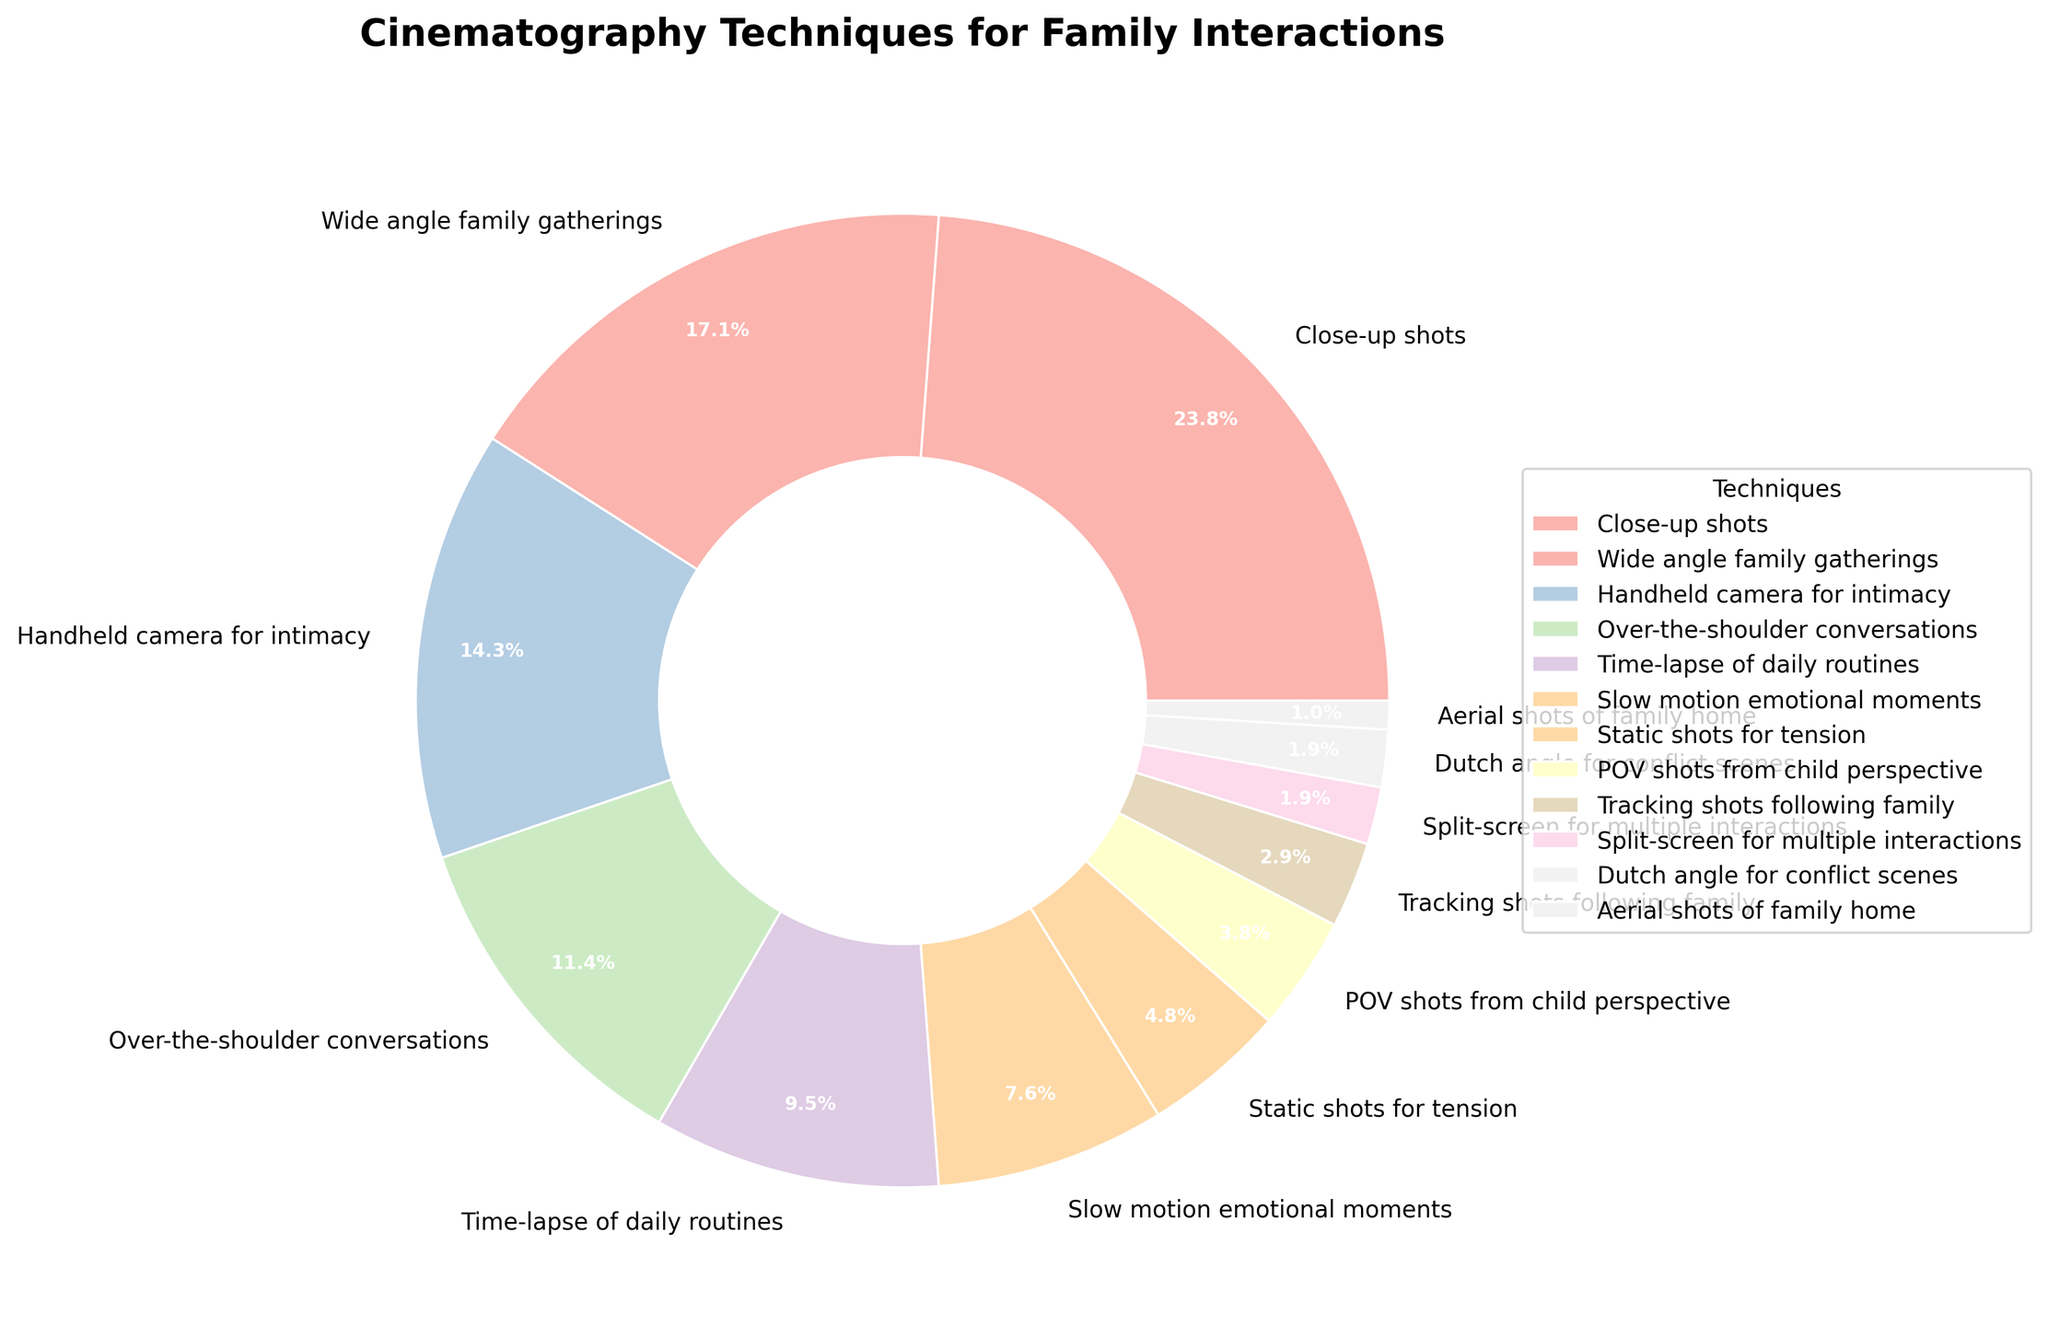what percentage of the chart is represented by Close-up shots, Wide angle family gatherings, and Handheld camera for intimacy? Close-up shots represent 25%, Wide angle family gatherings represent 18%, and Handheld camera for intimacy represents 15%. Adding these percentages: 25% + 18% + 15% = 58%.
Answer: 58% Which cinematography technique has the smallest percentage in the chart? The chart shows aerial shots of family home at 1%, which is the smallest percentage represented.
Answer: Aerial shots of family home Is the percentage for Slow motion emotional moments greater than the combined percentage of Dutch angle for conflict scenes and Split-screen for multiple interactions? Slow motion emotional moments have a percentage of 8%. Together, Dutch angle for conflict scenes and Split-screen for multiple interactions sum to 2% + 2% = 4%. Therefore, 8% is greater than 4%.
Answer: Yes What is the visual distinguishing feature of the wedges representing Close-up shots and Wide angle family gatherings? Close-up shots and Wide angle family gatherings are distinguished by their proportions relative to the other segments. Close-up shots show a larger segment (25%) compared to Wide angle family gatherings (18%). Their colors and positions around the pie chart also help distinguish them.
Answer: Larger size for Close-up shots Which three techniques together form approximately half of the chart? Close-up shots (25%), Wide angle family gatherings (18%), and Handheld camera for intimacy (15%) together form 25% + 18% + 15% = 58%, which is slightly more than half of the chart.
Answer: Close-up shots, Wide angle family gatherings, Handheld camera for intimacy How does the percentage for Over-the-shoulder conversations compare to that of Time-lapse of daily routines? Over-the-shoulder conversations have a percentage of 12%, while Time-lapse of daily routines have a percentage of 10%. Therefore, Over-the-shoulder conversations have a higher percentage.
Answer: More What percentage do Slow motion emotional moments and Static shots for tension represent together? Slow motion emotional moments represent 8% and Static shots for tension represent 5%. Adding these: 8% + 5% = 13%.
Answer: 13% Which technique has a percentage closest to the value represented by Tracking shots following family? The percentage for Tracking shots following family is 3%. The closest percentage is from Split-screen for multiple interactions and Dutch angle for conflict scenes, each at 2%.
Answer: Split-screen for multiple interactions, Dutch angle for conflict scenes Describe the color of the wedge for POV shots from child perspective. Without specifying exact coding details, wedges in pie charts typically use distinct colors. POV shots from child perspective likely have their unique pastel color, different from other segments, which helps in identifying them visually.
Answer: Unique pastel color 